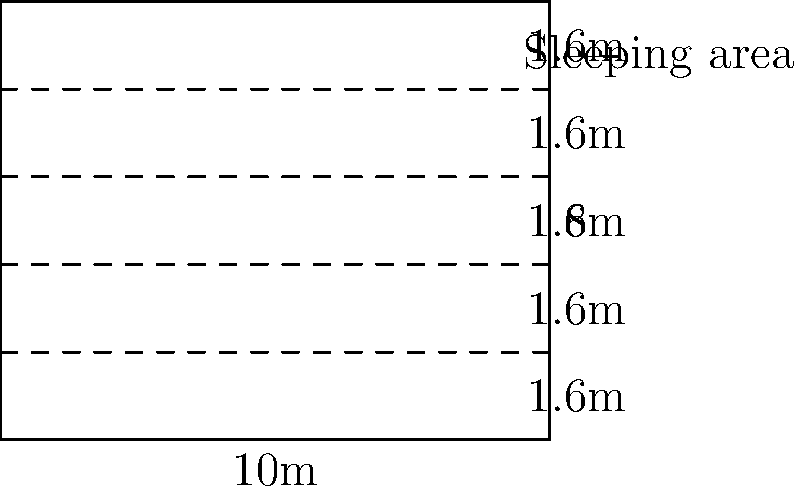A temporary refugee shelter measures 10m x 8m. The shelter is divided into 5 equal sleeping areas, each 1.6m wide. If each refugee requires a minimum of 3.5 square meters of space, what is the maximum number of refugees that can be accommodated in this shelter while complying with international humanitarian standards? To solve this problem, we need to follow these steps:

1. Calculate the total area of the shelter:
   Area = length × width
   Area = 10m × 8m = 80 square meters

2. Calculate the area of each sleeping section:
   Section area = length × width of section
   Section area = 10m × 1.6m = 16 square meters

3. Calculate the total number of sections:
   Number of sections = 5 (given in the question)

4. Verify that the total area matches the sum of section areas:
   Total area = Section area × Number of sections
   80 sq m = 16 sq m × 5 (This confirms our calculations are correct)

5. Calculate the number of refugees per section:
   Area per refugee = 3.5 sq m (given in the question)
   Refugees per section = Section area ÷ Area per refugee
   Refugees per section = 16 sq m ÷ 3.5 sq m ≈ 4.57

6. Since we can't accommodate fractional refugees, we round down to 4 refugees per section.

7. Calculate the total number of refugees:
   Total refugees = Refugees per section × Number of sections
   Total refugees = 4 × 5 = 20

Therefore, the maximum number of refugees that can be accommodated in this shelter while complying with international humanitarian standards is 20.
Answer: 20 refugees 